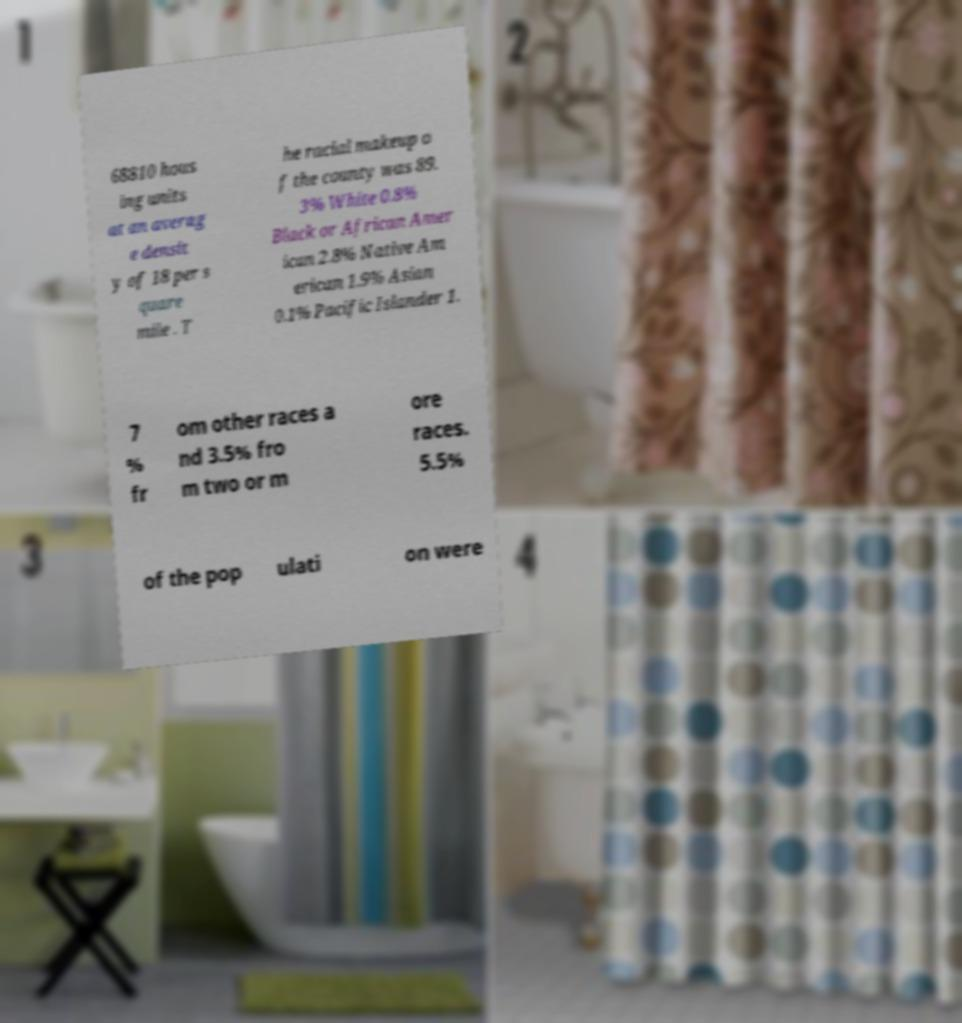Can you read and provide the text displayed in the image?This photo seems to have some interesting text. Can you extract and type it out for me? 68810 hous ing units at an averag e densit y of 18 per s quare mile . T he racial makeup o f the county was 89. 3% White 0.8% Black or African Amer ican 2.8% Native Am erican 1.9% Asian 0.1% Pacific Islander 1. 7 % fr om other races a nd 3.5% fro m two or m ore races. 5.5% of the pop ulati on were 